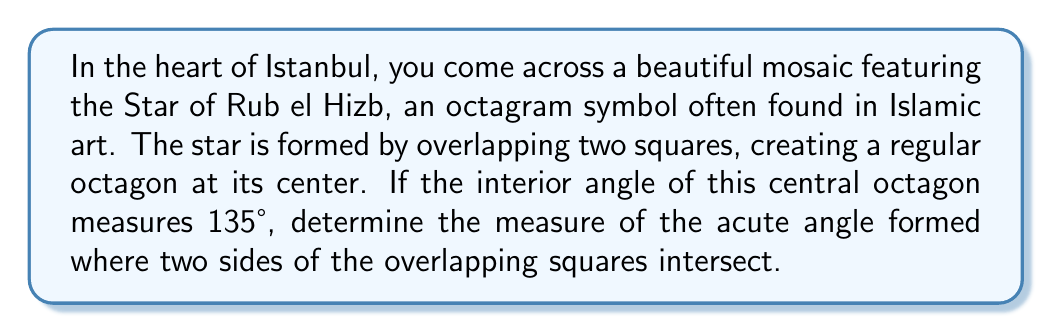Teach me how to tackle this problem. Let's approach this step-by-step:

1) First, recall that the sum of interior angles of any octagon is given by the formula:
   $$(n-2) \times 180°$$
   where $n$ is the number of sides. For an octagon, $n = 8$.

2) So, the sum of interior angles of an octagon is:
   $$(8-2) \times 180° = 6 \times 180° = 1080°$$

3) In a regular octagon, all interior angles are equal. Given that each interior angle measures 135°, we can verify:
   $$8 \times 135° = 1080°$$

4) Now, let's focus on the acute angle formed where two sides of the squares intersect. This angle is complementary to half of the octagon's interior angle.

5) Half of the octagon's interior angle is:
   $$\frac{135°}{2} = 67.5°$$

6) The acute angle we're looking for is complementary to 67.5°, meaning they add up to 90°. So we can find it by:
   $$90° - 67.5° = 22.5°$$

[asy]
unitsize(100);
path octagon = (1,0)--(cos(pi/4),sin(pi/4))--(-cos(pi/4),sin(pi/4))--(-1,0)--(-cos(pi/4),-sin(pi/4))--(cos(pi/4),-sin(pi/4))--cycle;
draw(octagon);
draw((1,0)--(-1,0));
draw((0,1)--(0,-1));
label("135°", (0.5,0.5), NE);
label("22.5°", (0.9,0.1), SE);
[/asy]

Therefore, the acute angle formed where two sides of the overlapping squares intersect measures 22.5°.
Answer: $22.5°$ 